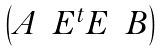Convert formula to latex. <formula><loc_0><loc_0><loc_500><loc_500>\begin{pmatrix} A & E ^ { t } E & B \end{pmatrix}</formula> 